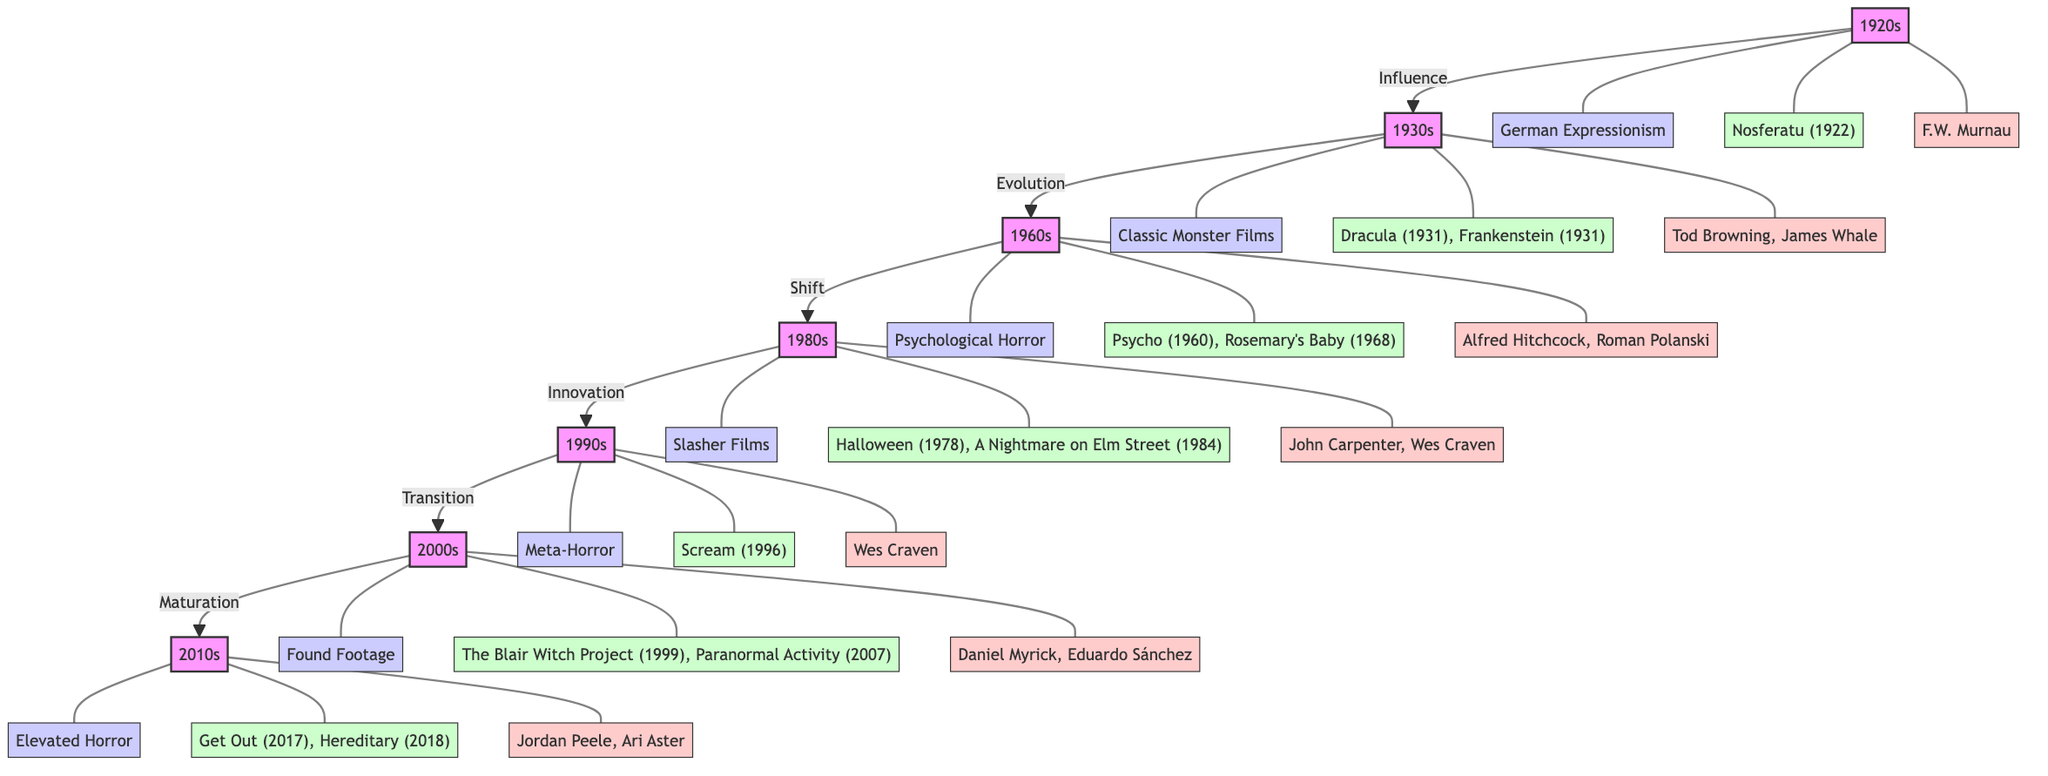What is the main horror film subgenre of the 1980s? The diagram identifies 1980s as the decade with the subgenre "Slasher Films" connected to the 1980s node.
Answer: Slasher Films Which directors are associated with the 1920s? By tracing the connection from the 1920s decade node, the diagram lists "F.W. Murnau" under the directors associated with that decade.
Answer: F.W. Murnau How many decades are represented in the diagram? The diagram contains seven distinct decade nodes, which can be counted directly from the flowchart.
Answer: 7 What type of evolution does the diagram show between the 1980s and the 1990s? The arrow between the 1980s and 1990s nodes is labeled "Innovation," indicating the relationship between these two decades.
Answer: Innovation Name one key example from the 2000s genre. The key example from the 2000s description node is "The Blair Witch Project (1999)," which is mentioned under the connected example.
Answer: The Blair Witch Project (1999) Which influential director is linked to the psychological horror of the 1960s? The 1960s node points to two directors, including "Alfred Hitchcock," who is well-known for contributions to psychological horror films.
Answer: Alfred Hitchcock What is the immediate predecessor of the "Elevated Horror" subgenre? The flowchart shows a direct connection from the 2000s, whose final designation is "Found Footage," to the 2010s, which features "Elevated Horror." This indicates that "Found Footage" is the predecessor.
Answer: Found Footage Which decade features key examples such as "Dracula" and "Frankenstein"? By examining the connections in the diagram, the 1930s decade is associated with the examples "Dracula (1931), Frankenstein (1931)."
Answer: 1930s What type of horror is represented in the 1990s? The diagram shows that the horror subgenre for the 1990s is labeled as "Meta-Horror," directly connecting it to the 1990s decade.
Answer: Meta-Horror 